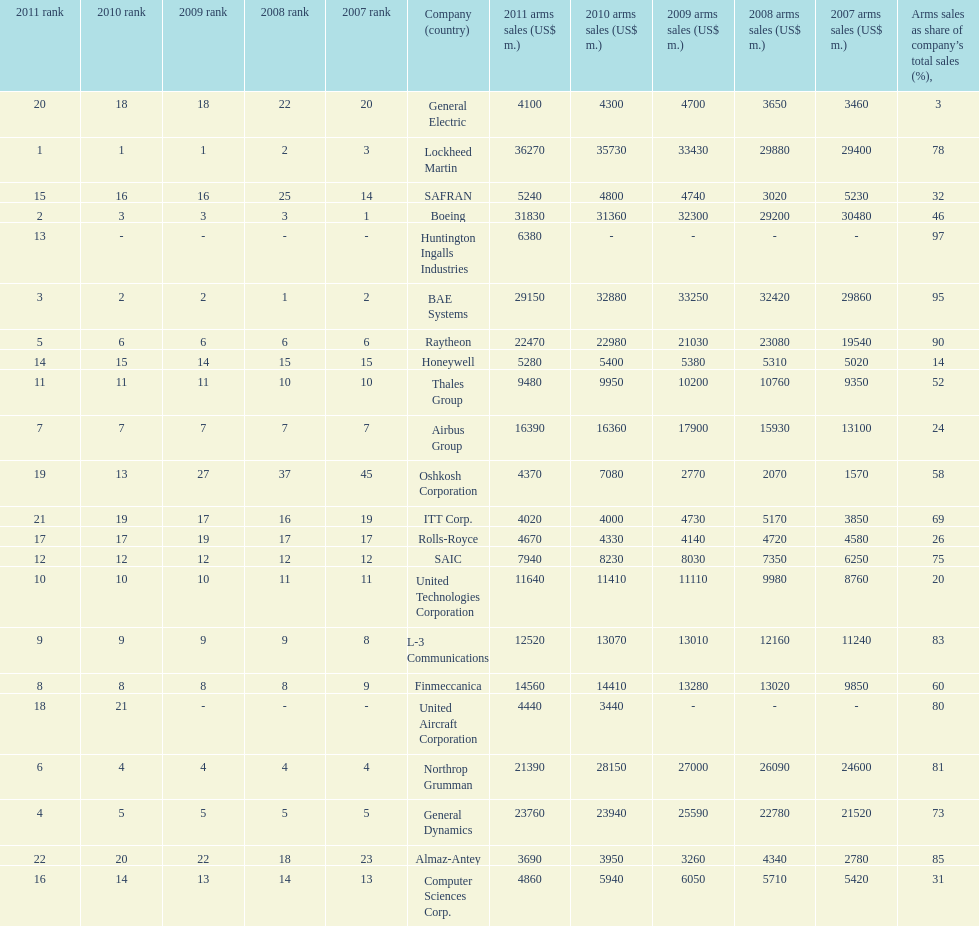Name all the companies whose arms sales as share of company's total sales is below 75%. Boeing, General Dynamics, Airbus Group, Finmeccanica, United Technologies Corporation, Thales Group, Honeywell, SAFRAN, Computer Sciences Corp., Rolls-Royce, Oshkosh Corporation, General Electric, ITT Corp. 